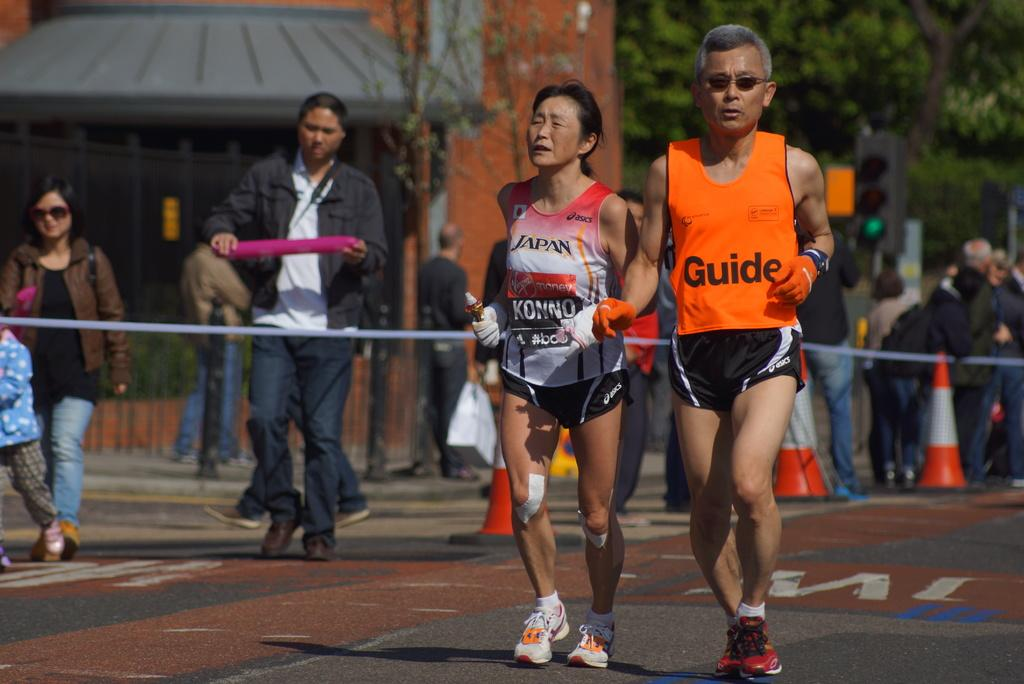Provide a one-sentence caption for the provided image. A photo of a race with the a man having the word Guide on his jersey. 